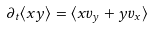Convert formula to latex. <formula><loc_0><loc_0><loc_500><loc_500>\partial _ { t } \langle x y \rangle = \langle x v _ { y } + y v _ { x } \rangle</formula> 